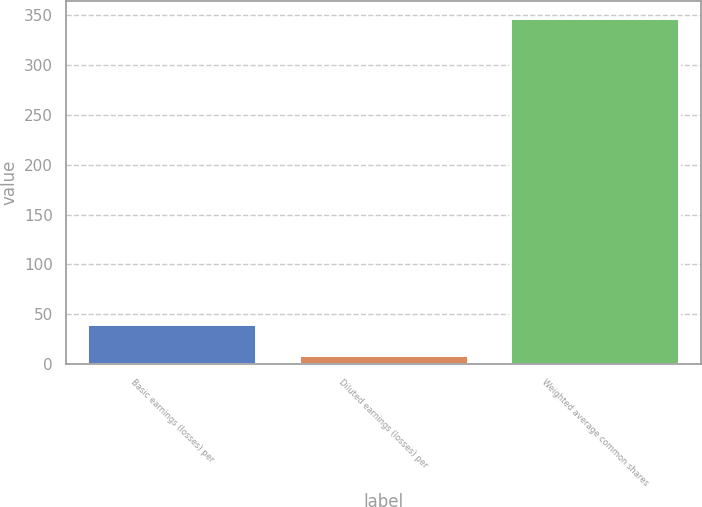Convert chart. <chart><loc_0><loc_0><loc_500><loc_500><bar_chart><fcel>Basic earnings (losses) per<fcel>Diluted earnings (losses) per<fcel>Weighted average common shares<nl><fcel>40.23<fcel>9.24<fcel>347.29<nl></chart> 